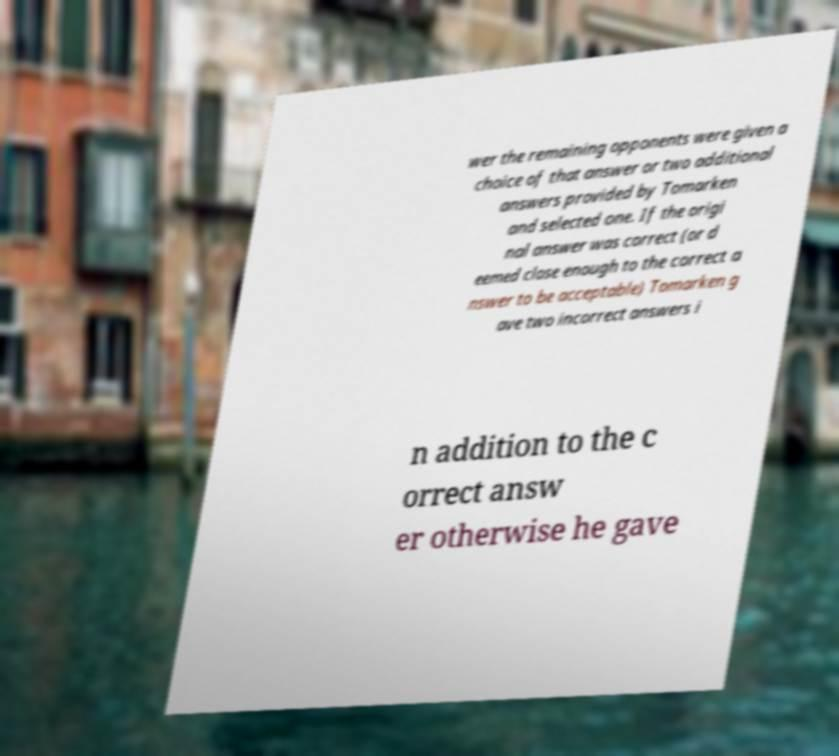Please identify and transcribe the text found in this image. wer the remaining opponents were given a choice of that answer or two additional answers provided by Tomarken and selected one. If the origi nal answer was correct (or d eemed close enough to the correct a nswer to be acceptable) Tomarken g ave two incorrect answers i n addition to the c orrect answ er otherwise he gave 